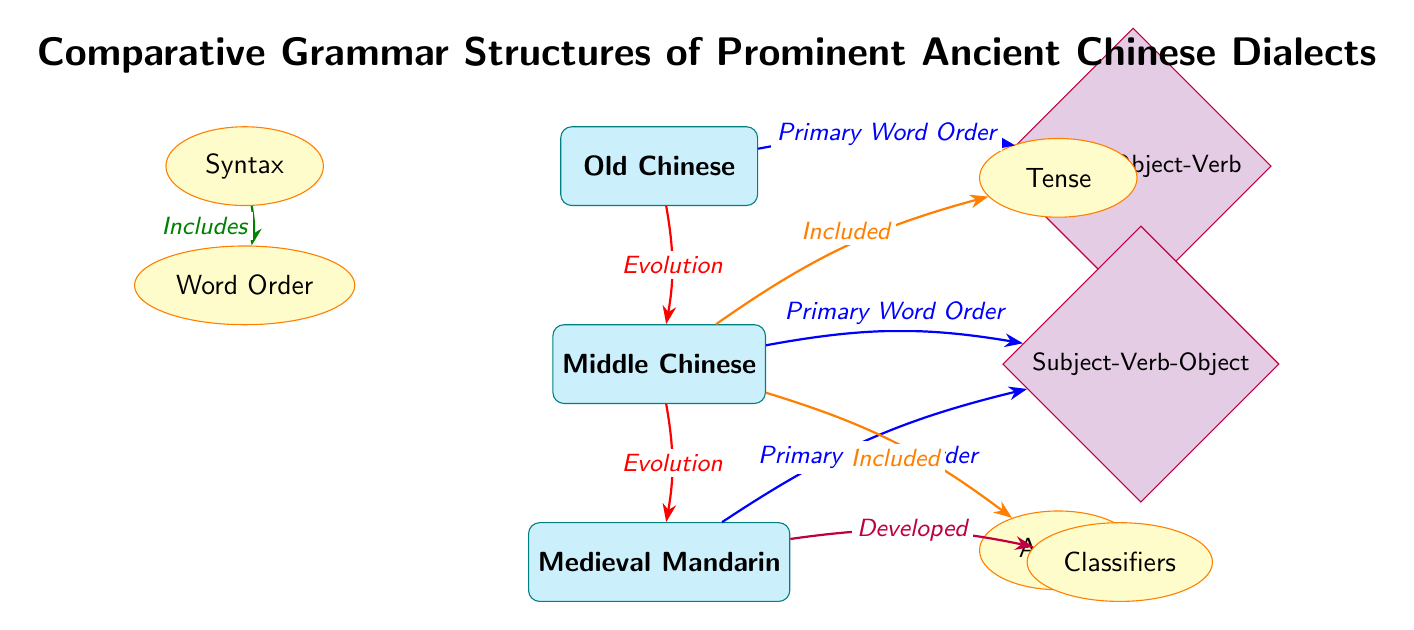What are the three dialects shown in the diagram? The diagram features three dialects: Old Chinese, Middle Chinese, and Medieval Mandarin, which are clearly labeled in rectangular nodes.
Answer: Old Chinese, Middle Chinese, Medieval Mandarin What is the primary word order of Old Chinese? The diagram indicates that the primary word order of Old Chinese is Subject-Object-Verb, as shown by the arrow connecting Old Chinese to the respective structure node.
Answer: Subject-Object-Verb How many features are included for Middle Chinese? The diagram shows two features branching off from Middle Chinese: tense and aspect. Therefore, there are two features included.
Answer: 2 Which dialect developed classifiers? The diagram indicates that classifiers were developed from Medieval Mandarin, as evidenced by the arrow from Medieval Mandarin leading to the classifiers node.
Answer: Medieval Mandarin What is the relationship between Middle Chinese and Old Chinese? The diagram shows that Middle Chinese evolved from Old Chinese, represented by a red arrow indicating evolution from one dialect to the next.
Answer: Evolution Which feature does syntax include? The arrow connecting the syntax node to the word order node shows that syntax includes word order as a sub-category.
Answer: Word Order What type of node is used to represent the dialects? The dialects are represented using rectangular nodes, as specified by the "dialect" style in the diagram.
Answer: Rectangle What color are the feature nodes? The feature nodes are colored yellow, as shown in the diagram's styling for features which specifies an orange ellipse filled with yellow.
Answer: Yellow How many primary word orders are represented in the diagram? There are two primary word orders indicated: Subject-Object-Verb and Subject-Verb-Object, one for Old Chinese and one for Middle Chinese and Medieval Mandarin.
Answer: 2 